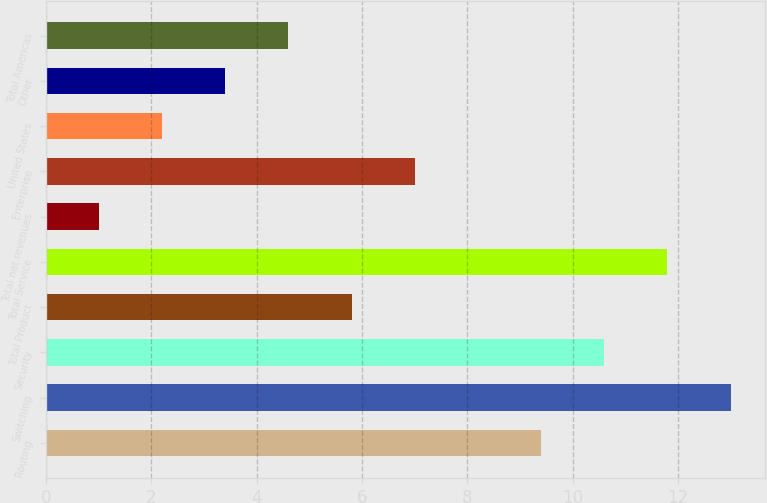Convert chart to OTSL. <chart><loc_0><loc_0><loc_500><loc_500><bar_chart><fcel>Routing<fcel>Switching<fcel>Security<fcel>Total Product<fcel>Total Service<fcel>Total net revenues<fcel>Enterprise<fcel>United States<fcel>Other<fcel>Total Americas<nl><fcel>9.4<fcel>13<fcel>10.6<fcel>5.8<fcel>11.8<fcel>1<fcel>7<fcel>2.2<fcel>3.4<fcel>4.6<nl></chart> 